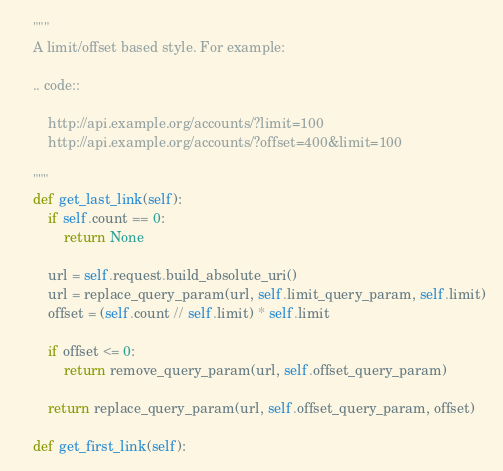Convert code to text. <code><loc_0><loc_0><loc_500><loc_500><_Python_>    """
    A limit/offset based style. For example:

    .. code::

        http://api.example.org/accounts/?limit=100
        http://api.example.org/accounts/?offset=400&limit=100

    """
    def get_last_link(self):
        if self.count == 0:
            return None

        url = self.request.build_absolute_uri()
        url = replace_query_param(url, self.limit_query_param, self.limit)
        offset = (self.count // self.limit) * self.limit

        if offset <= 0:
            return remove_query_param(url, self.offset_query_param)

        return replace_query_param(url, self.offset_query_param, offset)

    def get_first_link(self):</code> 